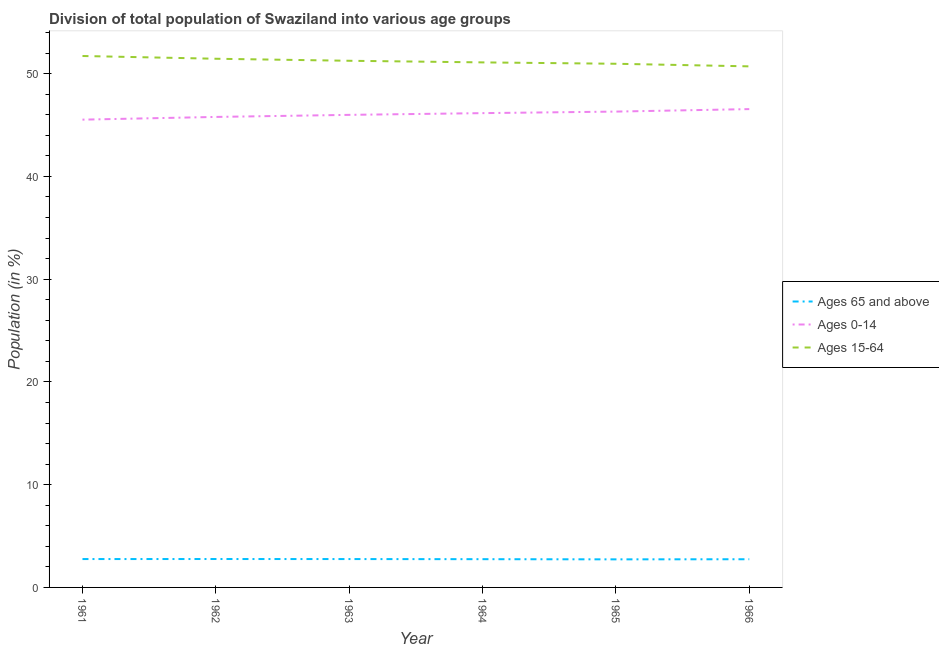What is the percentage of population within the age-group 0-14 in 1961?
Keep it short and to the point. 45.52. Across all years, what is the maximum percentage of population within the age-group 0-14?
Make the answer very short. 46.55. Across all years, what is the minimum percentage of population within the age-group 15-64?
Provide a short and direct response. 50.71. In which year was the percentage of population within the age-group 15-64 minimum?
Your answer should be very brief. 1966. What is the total percentage of population within the age-group 15-64 in the graph?
Ensure brevity in your answer.  307.18. What is the difference between the percentage of population within the age-group 0-14 in 1963 and that in 1964?
Ensure brevity in your answer.  -0.17. What is the difference between the percentage of population within the age-group 0-14 in 1962 and the percentage of population within the age-group 15-64 in 1966?
Give a very brief answer. -4.92. What is the average percentage of population within the age-group 0-14 per year?
Give a very brief answer. 46.05. In the year 1964, what is the difference between the percentage of population within the age-group 0-14 and percentage of population within the age-group of 65 and above?
Give a very brief answer. 43.41. In how many years, is the percentage of population within the age-group 15-64 greater than 24 %?
Offer a terse response. 6. What is the ratio of the percentage of population within the age-group of 65 and above in 1961 to that in 1963?
Provide a short and direct response. 1. What is the difference between the highest and the second highest percentage of population within the age-group 15-64?
Your answer should be compact. 0.27. What is the difference between the highest and the lowest percentage of population within the age-group of 65 and above?
Make the answer very short. 0.03. Is it the case that in every year, the sum of the percentage of population within the age-group of 65 and above and percentage of population within the age-group 0-14 is greater than the percentage of population within the age-group 15-64?
Offer a very short reply. No. Is the percentage of population within the age-group 0-14 strictly greater than the percentage of population within the age-group of 65 and above over the years?
Offer a very short reply. Yes. Is the percentage of population within the age-group 15-64 strictly less than the percentage of population within the age-group 0-14 over the years?
Give a very brief answer. No. How many lines are there?
Provide a short and direct response. 3. What is the difference between two consecutive major ticks on the Y-axis?
Your response must be concise. 10. Are the values on the major ticks of Y-axis written in scientific E-notation?
Provide a short and direct response. No. Does the graph contain any zero values?
Offer a terse response. No. Does the graph contain grids?
Your answer should be very brief. No. How are the legend labels stacked?
Provide a succinct answer. Vertical. What is the title of the graph?
Keep it short and to the point. Division of total population of Swaziland into various age groups
. What is the label or title of the X-axis?
Offer a very short reply. Year. What is the Population (in %) of Ages 65 and above in 1961?
Your response must be concise. 2.76. What is the Population (in %) of Ages 0-14 in 1961?
Offer a very short reply. 45.52. What is the Population (in %) of Ages 15-64 in 1961?
Your answer should be compact. 51.72. What is the Population (in %) of Ages 65 and above in 1962?
Ensure brevity in your answer.  2.76. What is the Population (in %) in Ages 0-14 in 1962?
Make the answer very short. 45.79. What is the Population (in %) of Ages 15-64 in 1962?
Your answer should be very brief. 51.45. What is the Population (in %) of Ages 65 and above in 1963?
Your answer should be very brief. 2.76. What is the Population (in %) in Ages 0-14 in 1963?
Ensure brevity in your answer.  45.99. What is the Population (in %) in Ages 15-64 in 1963?
Your answer should be very brief. 51.25. What is the Population (in %) in Ages 65 and above in 1964?
Offer a very short reply. 2.75. What is the Population (in %) in Ages 0-14 in 1964?
Provide a short and direct response. 46.16. What is the Population (in %) in Ages 15-64 in 1964?
Your response must be concise. 51.09. What is the Population (in %) in Ages 65 and above in 1965?
Keep it short and to the point. 2.73. What is the Population (in %) in Ages 0-14 in 1965?
Ensure brevity in your answer.  46.31. What is the Population (in %) in Ages 15-64 in 1965?
Your response must be concise. 50.96. What is the Population (in %) in Ages 65 and above in 1966?
Your response must be concise. 2.74. What is the Population (in %) in Ages 0-14 in 1966?
Offer a terse response. 46.55. What is the Population (in %) of Ages 15-64 in 1966?
Your answer should be very brief. 50.71. Across all years, what is the maximum Population (in %) in Ages 65 and above?
Your answer should be compact. 2.76. Across all years, what is the maximum Population (in %) of Ages 0-14?
Keep it short and to the point. 46.55. Across all years, what is the maximum Population (in %) in Ages 15-64?
Provide a succinct answer. 51.72. Across all years, what is the minimum Population (in %) of Ages 65 and above?
Keep it short and to the point. 2.73. Across all years, what is the minimum Population (in %) in Ages 0-14?
Provide a succinct answer. 45.52. Across all years, what is the minimum Population (in %) of Ages 15-64?
Provide a short and direct response. 50.71. What is the total Population (in %) in Ages 65 and above in the graph?
Ensure brevity in your answer.  16.51. What is the total Population (in %) in Ages 0-14 in the graph?
Your answer should be very brief. 276.31. What is the total Population (in %) of Ages 15-64 in the graph?
Your response must be concise. 307.18. What is the difference between the Population (in %) in Ages 65 and above in 1961 and that in 1962?
Ensure brevity in your answer.  -0. What is the difference between the Population (in %) of Ages 0-14 in 1961 and that in 1962?
Give a very brief answer. -0.26. What is the difference between the Population (in %) of Ages 15-64 in 1961 and that in 1962?
Ensure brevity in your answer.  0.27. What is the difference between the Population (in %) in Ages 65 and above in 1961 and that in 1963?
Make the answer very short. 0. What is the difference between the Population (in %) of Ages 0-14 in 1961 and that in 1963?
Your answer should be very brief. -0.47. What is the difference between the Population (in %) of Ages 15-64 in 1961 and that in 1963?
Keep it short and to the point. 0.47. What is the difference between the Population (in %) of Ages 65 and above in 1961 and that in 1964?
Offer a very short reply. 0.01. What is the difference between the Population (in %) in Ages 0-14 in 1961 and that in 1964?
Ensure brevity in your answer.  -0.63. What is the difference between the Population (in %) in Ages 15-64 in 1961 and that in 1964?
Offer a very short reply. 0.62. What is the difference between the Population (in %) of Ages 65 and above in 1961 and that in 1965?
Make the answer very short. 0.03. What is the difference between the Population (in %) of Ages 0-14 in 1961 and that in 1965?
Offer a terse response. -0.78. What is the difference between the Population (in %) in Ages 15-64 in 1961 and that in 1965?
Provide a succinct answer. 0.76. What is the difference between the Population (in %) in Ages 65 and above in 1961 and that in 1966?
Offer a terse response. 0.02. What is the difference between the Population (in %) of Ages 0-14 in 1961 and that in 1966?
Your answer should be compact. -1.03. What is the difference between the Population (in %) of Ages 15-64 in 1961 and that in 1966?
Provide a short and direct response. 1.01. What is the difference between the Population (in %) of Ages 65 and above in 1962 and that in 1963?
Your answer should be very brief. 0. What is the difference between the Population (in %) of Ages 0-14 in 1962 and that in 1963?
Keep it short and to the point. -0.2. What is the difference between the Population (in %) in Ages 15-64 in 1962 and that in 1963?
Provide a succinct answer. 0.2. What is the difference between the Population (in %) of Ages 65 and above in 1962 and that in 1964?
Offer a very short reply. 0.02. What is the difference between the Population (in %) in Ages 0-14 in 1962 and that in 1964?
Keep it short and to the point. -0.37. What is the difference between the Population (in %) of Ages 15-64 in 1962 and that in 1964?
Provide a short and direct response. 0.35. What is the difference between the Population (in %) of Ages 65 and above in 1962 and that in 1965?
Give a very brief answer. 0.03. What is the difference between the Population (in %) in Ages 0-14 in 1962 and that in 1965?
Your answer should be very brief. -0.52. What is the difference between the Population (in %) of Ages 15-64 in 1962 and that in 1965?
Provide a short and direct response. 0.49. What is the difference between the Population (in %) of Ages 65 and above in 1962 and that in 1966?
Provide a short and direct response. 0.02. What is the difference between the Population (in %) of Ages 0-14 in 1962 and that in 1966?
Keep it short and to the point. -0.76. What is the difference between the Population (in %) in Ages 15-64 in 1962 and that in 1966?
Your answer should be very brief. 0.74. What is the difference between the Population (in %) of Ages 65 and above in 1963 and that in 1964?
Your answer should be very brief. 0.01. What is the difference between the Population (in %) in Ages 0-14 in 1963 and that in 1964?
Your response must be concise. -0.17. What is the difference between the Population (in %) of Ages 15-64 in 1963 and that in 1964?
Provide a succinct answer. 0.16. What is the difference between the Population (in %) of Ages 65 and above in 1963 and that in 1965?
Offer a terse response. 0.03. What is the difference between the Population (in %) in Ages 0-14 in 1963 and that in 1965?
Make the answer very short. -0.32. What is the difference between the Population (in %) in Ages 15-64 in 1963 and that in 1965?
Your answer should be compact. 0.29. What is the difference between the Population (in %) in Ages 65 and above in 1963 and that in 1966?
Offer a very short reply. 0.02. What is the difference between the Population (in %) in Ages 0-14 in 1963 and that in 1966?
Keep it short and to the point. -0.56. What is the difference between the Population (in %) in Ages 15-64 in 1963 and that in 1966?
Make the answer very short. 0.54. What is the difference between the Population (in %) in Ages 65 and above in 1964 and that in 1965?
Make the answer very short. 0.02. What is the difference between the Population (in %) of Ages 0-14 in 1964 and that in 1965?
Provide a succinct answer. -0.15. What is the difference between the Population (in %) of Ages 15-64 in 1964 and that in 1965?
Provide a short and direct response. 0.13. What is the difference between the Population (in %) in Ages 65 and above in 1964 and that in 1966?
Your answer should be very brief. 0.01. What is the difference between the Population (in %) in Ages 0-14 in 1964 and that in 1966?
Ensure brevity in your answer.  -0.39. What is the difference between the Population (in %) in Ages 15-64 in 1964 and that in 1966?
Your answer should be very brief. 0.39. What is the difference between the Population (in %) of Ages 65 and above in 1965 and that in 1966?
Provide a short and direct response. -0.01. What is the difference between the Population (in %) in Ages 0-14 in 1965 and that in 1966?
Provide a succinct answer. -0.24. What is the difference between the Population (in %) of Ages 15-64 in 1965 and that in 1966?
Keep it short and to the point. 0.25. What is the difference between the Population (in %) in Ages 65 and above in 1961 and the Population (in %) in Ages 0-14 in 1962?
Provide a short and direct response. -43.03. What is the difference between the Population (in %) of Ages 65 and above in 1961 and the Population (in %) of Ages 15-64 in 1962?
Offer a terse response. -48.69. What is the difference between the Population (in %) of Ages 0-14 in 1961 and the Population (in %) of Ages 15-64 in 1962?
Your answer should be compact. -5.93. What is the difference between the Population (in %) of Ages 65 and above in 1961 and the Population (in %) of Ages 0-14 in 1963?
Provide a succinct answer. -43.23. What is the difference between the Population (in %) of Ages 65 and above in 1961 and the Population (in %) of Ages 15-64 in 1963?
Make the answer very short. -48.49. What is the difference between the Population (in %) in Ages 0-14 in 1961 and the Population (in %) in Ages 15-64 in 1963?
Offer a very short reply. -5.73. What is the difference between the Population (in %) in Ages 65 and above in 1961 and the Population (in %) in Ages 0-14 in 1964?
Keep it short and to the point. -43.4. What is the difference between the Population (in %) of Ages 65 and above in 1961 and the Population (in %) of Ages 15-64 in 1964?
Offer a very short reply. -48.33. What is the difference between the Population (in %) in Ages 0-14 in 1961 and the Population (in %) in Ages 15-64 in 1964?
Ensure brevity in your answer.  -5.57. What is the difference between the Population (in %) of Ages 65 and above in 1961 and the Population (in %) of Ages 0-14 in 1965?
Make the answer very short. -43.55. What is the difference between the Population (in %) of Ages 65 and above in 1961 and the Population (in %) of Ages 15-64 in 1965?
Provide a succinct answer. -48.2. What is the difference between the Population (in %) of Ages 0-14 in 1961 and the Population (in %) of Ages 15-64 in 1965?
Make the answer very short. -5.44. What is the difference between the Population (in %) of Ages 65 and above in 1961 and the Population (in %) of Ages 0-14 in 1966?
Provide a short and direct response. -43.79. What is the difference between the Population (in %) of Ages 65 and above in 1961 and the Population (in %) of Ages 15-64 in 1966?
Your response must be concise. -47.95. What is the difference between the Population (in %) of Ages 0-14 in 1961 and the Population (in %) of Ages 15-64 in 1966?
Offer a very short reply. -5.19. What is the difference between the Population (in %) in Ages 65 and above in 1962 and the Population (in %) in Ages 0-14 in 1963?
Offer a very short reply. -43.22. What is the difference between the Population (in %) in Ages 65 and above in 1962 and the Population (in %) in Ages 15-64 in 1963?
Keep it short and to the point. -48.49. What is the difference between the Population (in %) in Ages 0-14 in 1962 and the Population (in %) in Ages 15-64 in 1963?
Your response must be concise. -5.47. What is the difference between the Population (in %) of Ages 65 and above in 1962 and the Population (in %) of Ages 0-14 in 1964?
Make the answer very short. -43.39. What is the difference between the Population (in %) in Ages 65 and above in 1962 and the Population (in %) in Ages 15-64 in 1964?
Provide a succinct answer. -48.33. What is the difference between the Population (in %) of Ages 0-14 in 1962 and the Population (in %) of Ages 15-64 in 1964?
Offer a very short reply. -5.31. What is the difference between the Population (in %) of Ages 65 and above in 1962 and the Population (in %) of Ages 0-14 in 1965?
Provide a short and direct response. -43.54. What is the difference between the Population (in %) in Ages 65 and above in 1962 and the Population (in %) in Ages 15-64 in 1965?
Your answer should be very brief. -48.2. What is the difference between the Population (in %) of Ages 0-14 in 1962 and the Population (in %) of Ages 15-64 in 1965?
Ensure brevity in your answer.  -5.17. What is the difference between the Population (in %) in Ages 65 and above in 1962 and the Population (in %) in Ages 0-14 in 1966?
Your answer should be very brief. -43.78. What is the difference between the Population (in %) in Ages 65 and above in 1962 and the Population (in %) in Ages 15-64 in 1966?
Ensure brevity in your answer.  -47.94. What is the difference between the Population (in %) in Ages 0-14 in 1962 and the Population (in %) in Ages 15-64 in 1966?
Your response must be concise. -4.92. What is the difference between the Population (in %) in Ages 65 and above in 1963 and the Population (in %) in Ages 0-14 in 1964?
Make the answer very short. -43.4. What is the difference between the Population (in %) in Ages 65 and above in 1963 and the Population (in %) in Ages 15-64 in 1964?
Your response must be concise. -48.33. What is the difference between the Population (in %) of Ages 0-14 in 1963 and the Population (in %) of Ages 15-64 in 1964?
Provide a succinct answer. -5.11. What is the difference between the Population (in %) of Ages 65 and above in 1963 and the Population (in %) of Ages 0-14 in 1965?
Make the answer very short. -43.55. What is the difference between the Population (in %) in Ages 65 and above in 1963 and the Population (in %) in Ages 15-64 in 1965?
Offer a very short reply. -48.2. What is the difference between the Population (in %) in Ages 0-14 in 1963 and the Population (in %) in Ages 15-64 in 1965?
Make the answer very short. -4.97. What is the difference between the Population (in %) in Ages 65 and above in 1963 and the Population (in %) in Ages 0-14 in 1966?
Your response must be concise. -43.79. What is the difference between the Population (in %) in Ages 65 and above in 1963 and the Population (in %) in Ages 15-64 in 1966?
Provide a succinct answer. -47.95. What is the difference between the Population (in %) of Ages 0-14 in 1963 and the Population (in %) of Ages 15-64 in 1966?
Provide a succinct answer. -4.72. What is the difference between the Population (in %) in Ages 65 and above in 1964 and the Population (in %) in Ages 0-14 in 1965?
Offer a terse response. -43.56. What is the difference between the Population (in %) in Ages 65 and above in 1964 and the Population (in %) in Ages 15-64 in 1965?
Your answer should be compact. -48.21. What is the difference between the Population (in %) of Ages 0-14 in 1964 and the Population (in %) of Ages 15-64 in 1965?
Your response must be concise. -4.8. What is the difference between the Population (in %) of Ages 65 and above in 1964 and the Population (in %) of Ages 0-14 in 1966?
Give a very brief answer. -43.8. What is the difference between the Population (in %) of Ages 65 and above in 1964 and the Population (in %) of Ages 15-64 in 1966?
Your answer should be very brief. -47.96. What is the difference between the Population (in %) of Ages 0-14 in 1964 and the Population (in %) of Ages 15-64 in 1966?
Give a very brief answer. -4.55. What is the difference between the Population (in %) of Ages 65 and above in 1965 and the Population (in %) of Ages 0-14 in 1966?
Your response must be concise. -43.82. What is the difference between the Population (in %) in Ages 65 and above in 1965 and the Population (in %) in Ages 15-64 in 1966?
Your answer should be compact. -47.98. What is the difference between the Population (in %) in Ages 0-14 in 1965 and the Population (in %) in Ages 15-64 in 1966?
Ensure brevity in your answer.  -4.4. What is the average Population (in %) in Ages 65 and above per year?
Provide a short and direct response. 2.75. What is the average Population (in %) in Ages 0-14 per year?
Give a very brief answer. 46.05. What is the average Population (in %) of Ages 15-64 per year?
Ensure brevity in your answer.  51.2. In the year 1961, what is the difference between the Population (in %) of Ages 65 and above and Population (in %) of Ages 0-14?
Give a very brief answer. -42.76. In the year 1961, what is the difference between the Population (in %) of Ages 65 and above and Population (in %) of Ages 15-64?
Your answer should be compact. -48.96. In the year 1961, what is the difference between the Population (in %) of Ages 0-14 and Population (in %) of Ages 15-64?
Provide a succinct answer. -6.19. In the year 1962, what is the difference between the Population (in %) of Ages 65 and above and Population (in %) of Ages 0-14?
Your answer should be very brief. -43.02. In the year 1962, what is the difference between the Population (in %) in Ages 65 and above and Population (in %) in Ages 15-64?
Offer a terse response. -48.68. In the year 1962, what is the difference between the Population (in %) in Ages 0-14 and Population (in %) in Ages 15-64?
Ensure brevity in your answer.  -5.66. In the year 1963, what is the difference between the Population (in %) in Ages 65 and above and Population (in %) in Ages 0-14?
Provide a short and direct response. -43.23. In the year 1963, what is the difference between the Population (in %) of Ages 65 and above and Population (in %) of Ages 15-64?
Keep it short and to the point. -48.49. In the year 1963, what is the difference between the Population (in %) in Ages 0-14 and Population (in %) in Ages 15-64?
Ensure brevity in your answer.  -5.26. In the year 1964, what is the difference between the Population (in %) of Ages 65 and above and Population (in %) of Ages 0-14?
Your response must be concise. -43.41. In the year 1964, what is the difference between the Population (in %) of Ages 65 and above and Population (in %) of Ages 15-64?
Offer a terse response. -48.35. In the year 1964, what is the difference between the Population (in %) in Ages 0-14 and Population (in %) in Ages 15-64?
Your answer should be very brief. -4.94. In the year 1965, what is the difference between the Population (in %) in Ages 65 and above and Population (in %) in Ages 0-14?
Your answer should be very brief. -43.58. In the year 1965, what is the difference between the Population (in %) in Ages 65 and above and Population (in %) in Ages 15-64?
Ensure brevity in your answer.  -48.23. In the year 1965, what is the difference between the Population (in %) of Ages 0-14 and Population (in %) of Ages 15-64?
Make the answer very short. -4.65. In the year 1966, what is the difference between the Population (in %) of Ages 65 and above and Population (in %) of Ages 0-14?
Your answer should be very brief. -43.81. In the year 1966, what is the difference between the Population (in %) in Ages 65 and above and Population (in %) in Ages 15-64?
Offer a very short reply. -47.97. In the year 1966, what is the difference between the Population (in %) in Ages 0-14 and Population (in %) in Ages 15-64?
Your answer should be very brief. -4.16. What is the ratio of the Population (in %) of Ages 65 and above in 1961 to that in 1962?
Your response must be concise. 1. What is the ratio of the Population (in %) in Ages 0-14 in 1961 to that in 1962?
Your answer should be compact. 0.99. What is the ratio of the Population (in %) of Ages 15-64 in 1961 to that in 1963?
Your answer should be compact. 1.01. What is the ratio of the Population (in %) of Ages 0-14 in 1961 to that in 1964?
Your answer should be compact. 0.99. What is the ratio of the Population (in %) in Ages 15-64 in 1961 to that in 1964?
Offer a terse response. 1.01. What is the ratio of the Population (in %) of Ages 65 and above in 1961 to that in 1965?
Ensure brevity in your answer.  1.01. What is the ratio of the Population (in %) of Ages 0-14 in 1961 to that in 1965?
Ensure brevity in your answer.  0.98. What is the ratio of the Population (in %) of Ages 15-64 in 1961 to that in 1965?
Offer a very short reply. 1.01. What is the ratio of the Population (in %) in Ages 65 and above in 1961 to that in 1966?
Your response must be concise. 1.01. What is the ratio of the Population (in %) in Ages 0-14 in 1961 to that in 1966?
Your answer should be compact. 0.98. What is the ratio of the Population (in %) of Ages 15-64 in 1961 to that in 1966?
Offer a terse response. 1.02. What is the ratio of the Population (in %) of Ages 65 and above in 1962 to that in 1963?
Offer a terse response. 1. What is the ratio of the Population (in %) of Ages 65 and above in 1962 to that in 1964?
Ensure brevity in your answer.  1.01. What is the ratio of the Population (in %) of Ages 15-64 in 1962 to that in 1964?
Ensure brevity in your answer.  1.01. What is the ratio of the Population (in %) of Ages 15-64 in 1962 to that in 1965?
Your response must be concise. 1.01. What is the ratio of the Population (in %) of Ages 65 and above in 1962 to that in 1966?
Make the answer very short. 1.01. What is the ratio of the Population (in %) in Ages 0-14 in 1962 to that in 1966?
Your answer should be very brief. 0.98. What is the ratio of the Population (in %) in Ages 15-64 in 1962 to that in 1966?
Offer a terse response. 1.01. What is the ratio of the Population (in %) of Ages 65 and above in 1963 to that in 1964?
Your response must be concise. 1. What is the ratio of the Population (in %) of Ages 0-14 in 1963 to that in 1964?
Ensure brevity in your answer.  1. What is the ratio of the Population (in %) in Ages 65 and above in 1963 to that in 1965?
Keep it short and to the point. 1.01. What is the ratio of the Population (in %) in Ages 15-64 in 1963 to that in 1965?
Make the answer very short. 1.01. What is the ratio of the Population (in %) of Ages 0-14 in 1963 to that in 1966?
Your response must be concise. 0.99. What is the ratio of the Population (in %) in Ages 15-64 in 1963 to that in 1966?
Make the answer very short. 1.01. What is the ratio of the Population (in %) of Ages 0-14 in 1964 to that in 1965?
Provide a succinct answer. 1. What is the ratio of the Population (in %) in Ages 65 and above in 1964 to that in 1966?
Give a very brief answer. 1. What is the ratio of the Population (in %) of Ages 0-14 in 1964 to that in 1966?
Ensure brevity in your answer.  0.99. What is the ratio of the Population (in %) in Ages 15-64 in 1964 to that in 1966?
Keep it short and to the point. 1.01. What is the ratio of the Population (in %) of Ages 65 and above in 1965 to that in 1966?
Provide a short and direct response. 1. What is the ratio of the Population (in %) in Ages 15-64 in 1965 to that in 1966?
Ensure brevity in your answer.  1. What is the difference between the highest and the second highest Population (in %) of Ages 65 and above?
Keep it short and to the point. 0. What is the difference between the highest and the second highest Population (in %) of Ages 0-14?
Your answer should be very brief. 0.24. What is the difference between the highest and the second highest Population (in %) of Ages 15-64?
Offer a terse response. 0.27. What is the difference between the highest and the lowest Population (in %) of Ages 65 and above?
Your answer should be very brief. 0.03. What is the difference between the highest and the lowest Population (in %) in Ages 0-14?
Offer a terse response. 1.03. What is the difference between the highest and the lowest Population (in %) of Ages 15-64?
Your response must be concise. 1.01. 